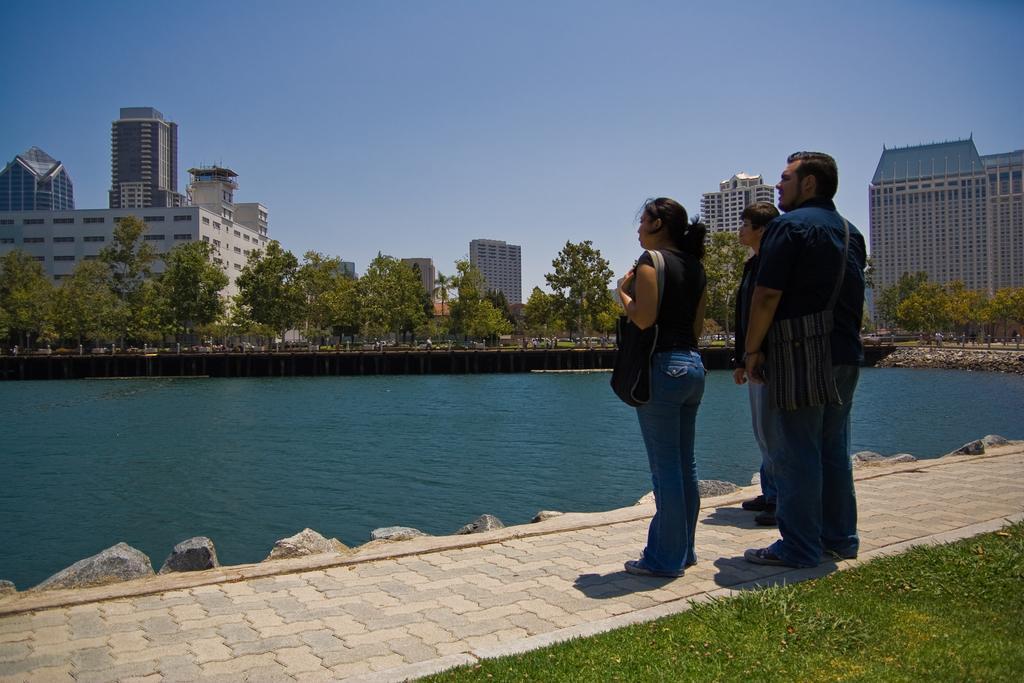How would you summarize this image in a sentence or two? In this image we can see group of people standing on the ground. A woman is wearing a bag. In the background we can see group of trees ,buildings ,a lake and sky. 